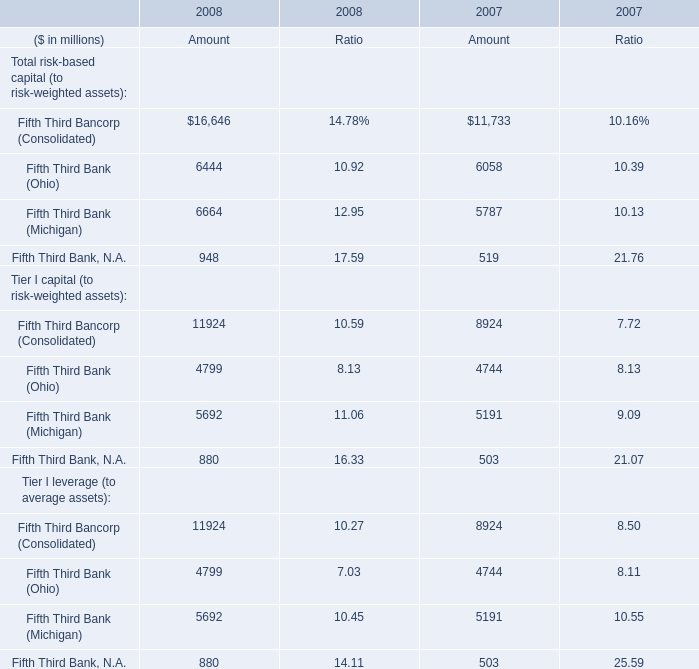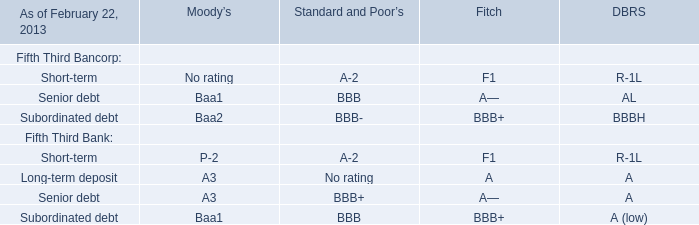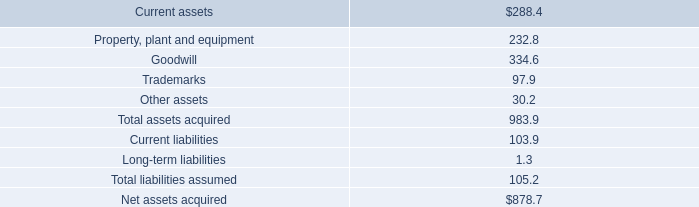In what year is Total risk-based capital (to risk-weighted assets) of Fifth Third Bank (Ohio) in terms of Amount positive? 
Answer: 2008. In which year is Total risk-based capital (to risk-weighted assets) of Fifth Third Bank (Ohio) greater than Total risk-based capital (to risk-weighted assets) of Fifth Third Bank (Michigan) for Amount? 
Answer: 2007. 